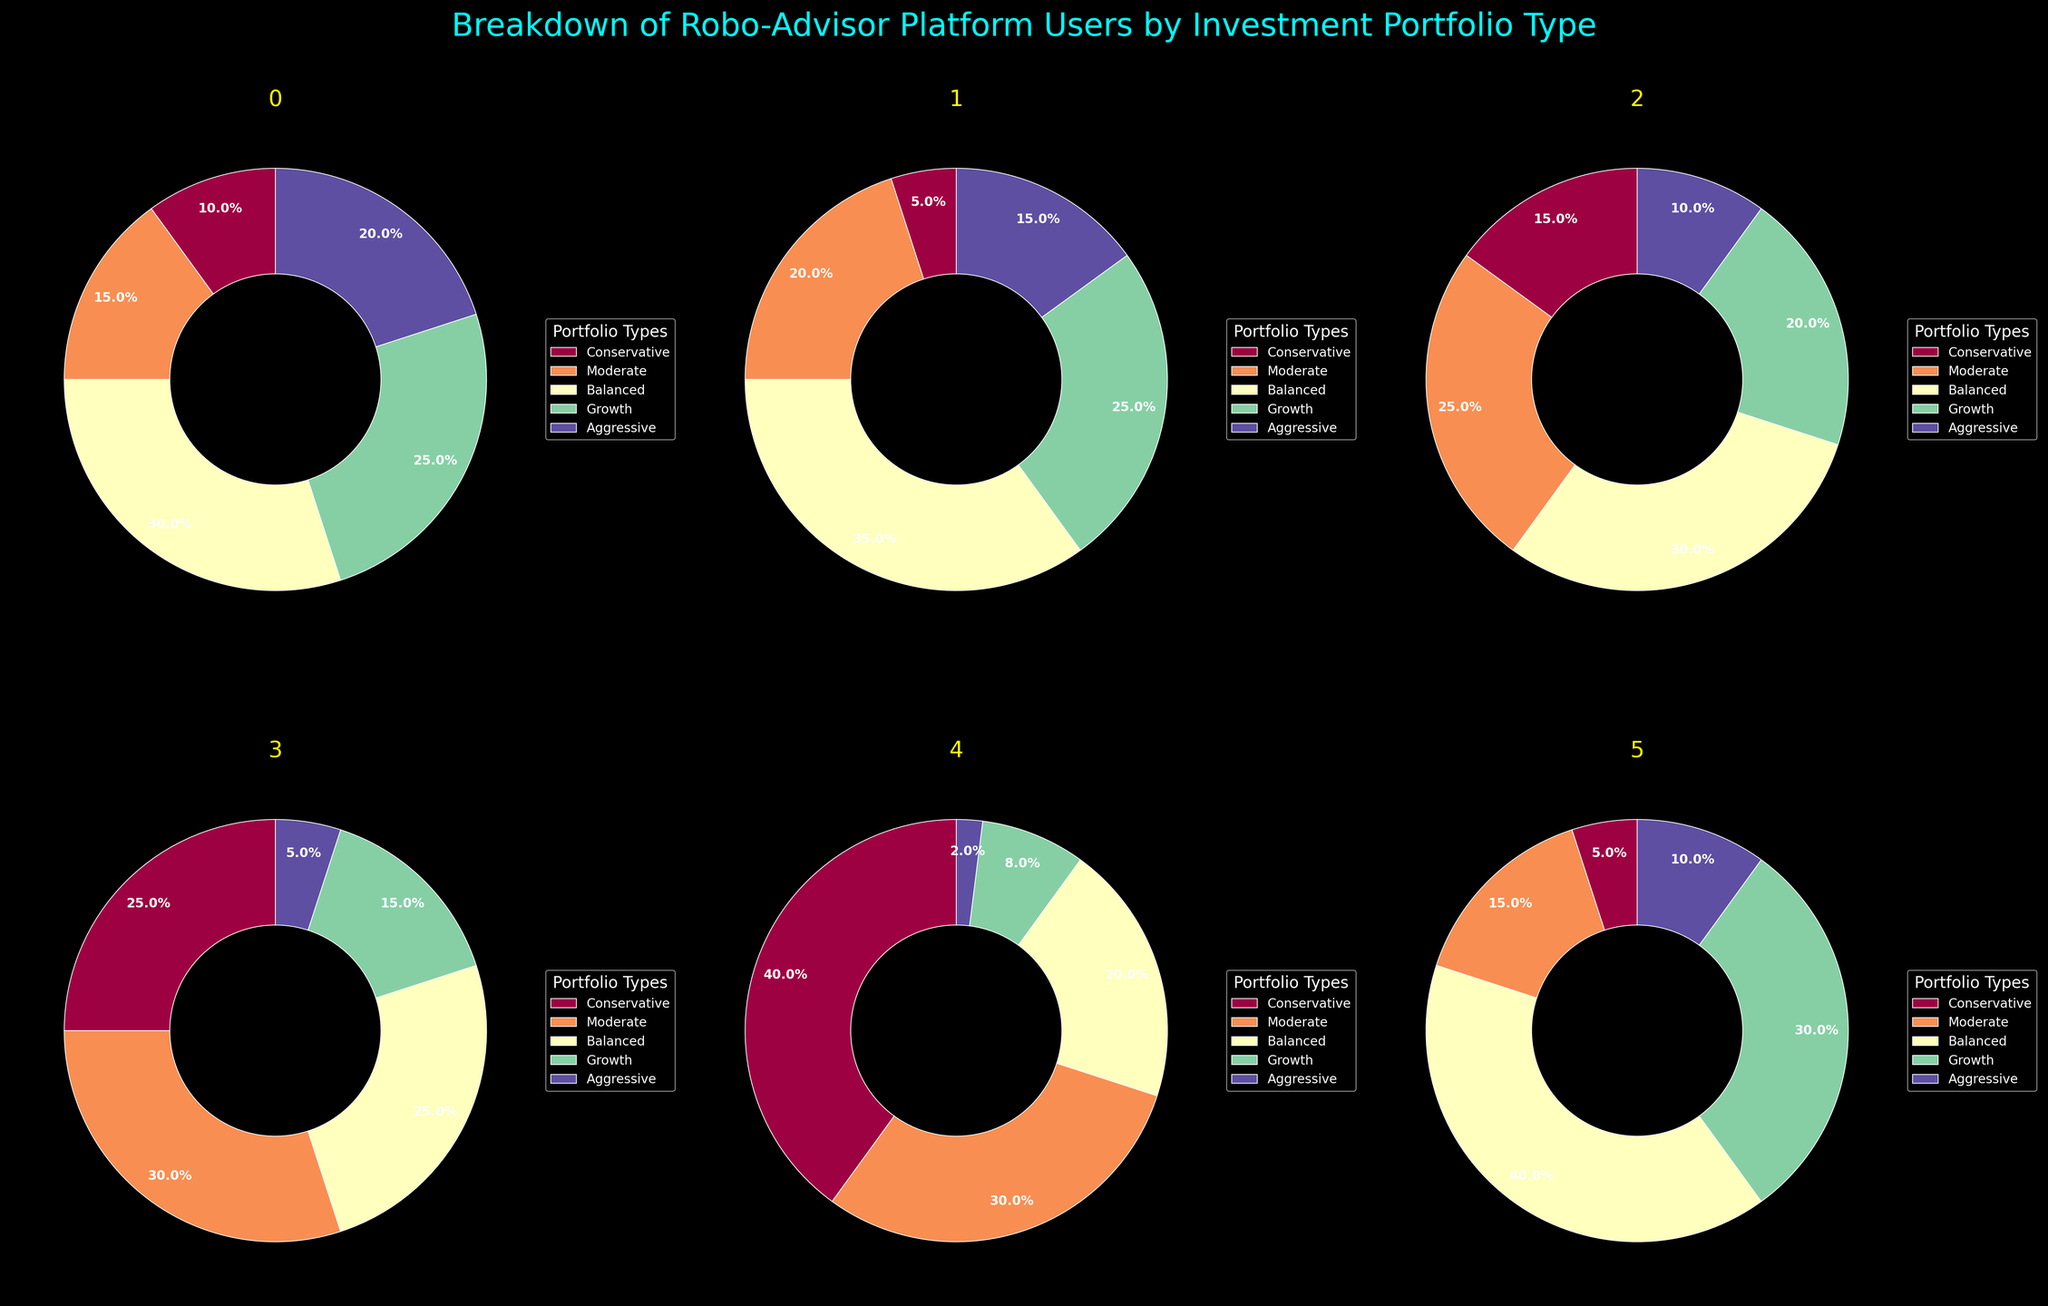Which age group has the highest percentage of users in the Conservative portfolio? By looking at the pie charts, we can see that the 56+ age group has the largest segment in the Conservative portfolio, occupying 40%.
Answer: 56+ age group What is the difference in percentage between the Aggressive portfolio of the 18-25 age group and the 46-55 age group? The Aggressive portfolio has 20% in the 18-25 age group and 5% in the 46-55 age group. Thus, the difference is 20% - 5% = 15%.
Answer: 15% Which two age groups have an equal percentage in the Moderate portfolio? By examining the pie charts, the 26-35 age group and Digital Nomads both have 15% in the Moderate portfolio.
Answer: 26-35 age group and Digital Nomads In the Growth portfolio, which age group has the second largest percentage, and what is that percentage? The highest in Growth portfolio is Digital Nomads with 30%, and the second highest is the 18-25 and 26-35 age group both with 25%.
Answer: 18-25 age group and 26-35 age group, 25% What are the portfolio types and their corresponding percentages for the Digital Nomads group? For the Digital Nomads, the portfolio types and percentages are as follows: Conservative 5%, Moderate 15%, Balanced 40%, Growth 30%, and Aggressive 10%.
Answer: Conservative 5%, Moderate 15%, Balanced 40%, Growth 30%, Aggressive 10% Which portfolio type is the most preferred by the 36-45 age group? By inspecting the pie chart for the 36-45 age group, the Balanced portfolio type has the highest percentage at 30%.
Answer: Balanced Among the 46-55 age group, what is the combined percentage for the Conservative and Balanced portfolios? The Conservative portfolio is 25% and the Balanced portfolio is 25%, thereby combining to 50%.
Answer: 50% What percentage of Digital Nomads are in the Aggressive portfolio? Observing the pie chart for Digital Nomads, the Aggressive portfolio segment represents 10%.
Answer: 10% In the 56+ age group, how much more is the Conservative portfolio compared to the Growth portfolio? The Conservative portfolio is 40% and the Growth portfolio is 8%; hence, the difference is 40% - 8% = 32%.
Answer: 32% 